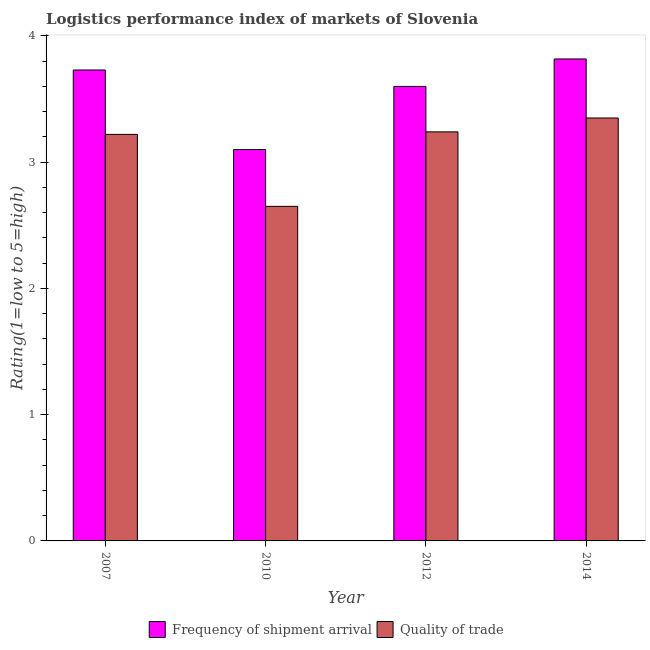How many groups of bars are there?
Provide a short and direct response. 4. Are the number of bars on each tick of the X-axis equal?
Ensure brevity in your answer.  Yes. What is the label of the 4th group of bars from the left?
Your answer should be compact. 2014. In how many cases, is the number of bars for a given year not equal to the number of legend labels?
Ensure brevity in your answer.  0. What is the lpi quality of trade in 2007?
Make the answer very short. 3.22. Across all years, what is the maximum lpi quality of trade?
Your answer should be compact. 3.35. Across all years, what is the minimum lpi quality of trade?
Offer a terse response. 2.65. In which year was the lpi quality of trade maximum?
Your answer should be compact. 2014. What is the total lpi quality of trade in the graph?
Provide a succinct answer. 12.46. What is the difference between the lpi of frequency of shipment arrival in 2007 and that in 2014?
Your answer should be very brief. -0.09. What is the difference between the lpi of frequency of shipment arrival in 2010 and the lpi quality of trade in 2014?
Offer a terse response. -0.72. What is the average lpi of frequency of shipment arrival per year?
Your response must be concise. 3.56. In the year 2012, what is the difference between the lpi quality of trade and lpi of frequency of shipment arrival?
Offer a terse response. 0. In how many years, is the lpi quality of trade greater than 3.6?
Your answer should be very brief. 0. What is the ratio of the lpi of frequency of shipment arrival in 2007 to that in 2014?
Keep it short and to the point. 0.98. What is the difference between the highest and the second highest lpi quality of trade?
Give a very brief answer. 0.11. What is the difference between the highest and the lowest lpi of frequency of shipment arrival?
Your response must be concise. 0.72. Is the sum of the lpi quality of trade in 2007 and 2010 greater than the maximum lpi of frequency of shipment arrival across all years?
Make the answer very short. Yes. What does the 1st bar from the left in 2014 represents?
Make the answer very short. Frequency of shipment arrival. What does the 1st bar from the right in 2007 represents?
Provide a short and direct response. Quality of trade. How many bars are there?
Give a very brief answer. 8. Are all the bars in the graph horizontal?
Make the answer very short. No. How many years are there in the graph?
Provide a succinct answer. 4. What is the difference between two consecutive major ticks on the Y-axis?
Offer a very short reply. 1. Does the graph contain grids?
Provide a short and direct response. No. What is the title of the graph?
Your response must be concise. Logistics performance index of markets of Slovenia. Does "Research and Development" appear as one of the legend labels in the graph?
Make the answer very short. No. What is the label or title of the Y-axis?
Give a very brief answer. Rating(1=low to 5=high). What is the Rating(1=low to 5=high) of Frequency of shipment arrival in 2007?
Provide a short and direct response. 3.73. What is the Rating(1=low to 5=high) in Quality of trade in 2007?
Your answer should be very brief. 3.22. What is the Rating(1=low to 5=high) of Frequency of shipment arrival in 2010?
Offer a very short reply. 3.1. What is the Rating(1=low to 5=high) in Quality of trade in 2010?
Your response must be concise. 2.65. What is the Rating(1=low to 5=high) in Frequency of shipment arrival in 2012?
Ensure brevity in your answer.  3.6. What is the Rating(1=low to 5=high) in Quality of trade in 2012?
Ensure brevity in your answer.  3.24. What is the Rating(1=low to 5=high) of Frequency of shipment arrival in 2014?
Give a very brief answer. 3.82. What is the Rating(1=low to 5=high) of Quality of trade in 2014?
Ensure brevity in your answer.  3.35. Across all years, what is the maximum Rating(1=low to 5=high) of Frequency of shipment arrival?
Give a very brief answer. 3.82. Across all years, what is the maximum Rating(1=low to 5=high) in Quality of trade?
Your response must be concise. 3.35. Across all years, what is the minimum Rating(1=low to 5=high) of Quality of trade?
Offer a terse response. 2.65. What is the total Rating(1=low to 5=high) in Frequency of shipment arrival in the graph?
Make the answer very short. 14.25. What is the total Rating(1=low to 5=high) in Quality of trade in the graph?
Ensure brevity in your answer.  12.46. What is the difference between the Rating(1=low to 5=high) in Frequency of shipment arrival in 2007 and that in 2010?
Make the answer very short. 0.63. What is the difference between the Rating(1=low to 5=high) of Quality of trade in 2007 and that in 2010?
Your response must be concise. 0.57. What is the difference between the Rating(1=low to 5=high) of Frequency of shipment arrival in 2007 and that in 2012?
Your answer should be compact. 0.13. What is the difference between the Rating(1=low to 5=high) in Quality of trade in 2007 and that in 2012?
Ensure brevity in your answer.  -0.02. What is the difference between the Rating(1=low to 5=high) in Frequency of shipment arrival in 2007 and that in 2014?
Offer a terse response. -0.09. What is the difference between the Rating(1=low to 5=high) of Quality of trade in 2007 and that in 2014?
Give a very brief answer. -0.13. What is the difference between the Rating(1=low to 5=high) in Quality of trade in 2010 and that in 2012?
Offer a very short reply. -0.59. What is the difference between the Rating(1=low to 5=high) in Frequency of shipment arrival in 2010 and that in 2014?
Your answer should be very brief. -0.72. What is the difference between the Rating(1=low to 5=high) in Quality of trade in 2010 and that in 2014?
Give a very brief answer. -0.7. What is the difference between the Rating(1=low to 5=high) of Frequency of shipment arrival in 2012 and that in 2014?
Provide a succinct answer. -0.22. What is the difference between the Rating(1=low to 5=high) of Quality of trade in 2012 and that in 2014?
Make the answer very short. -0.11. What is the difference between the Rating(1=low to 5=high) in Frequency of shipment arrival in 2007 and the Rating(1=low to 5=high) in Quality of trade in 2010?
Your response must be concise. 1.08. What is the difference between the Rating(1=low to 5=high) of Frequency of shipment arrival in 2007 and the Rating(1=low to 5=high) of Quality of trade in 2012?
Offer a terse response. 0.49. What is the difference between the Rating(1=low to 5=high) of Frequency of shipment arrival in 2007 and the Rating(1=low to 5=high) of Quality of trade in 2014?
Offer a very short reply. 0.38. What is the difference between the Rating(1=low to 5=high) of Frequency of shipment arrival in 2010 and the Rating(1=low to 5=high) of Quality of trade in 2012?
Provide a short and direct response. -0.14. What is the difference between the Rating(1=low to 5=high) of Frequency of shipment arrival in 2010 and the Rating(1=low to 5=high) of Quality of trade in 2014?
Your answer should be very brief. -0.25. What is the difference between the Rating(1=low to 5=high) of Frequency of shipment arrival in 2012 and the Rating(1=low to 5=high) of Quality of trade in 2014?
Your response must be concise. 0.25. What is the average Rating(1=low to 5=high) of Frequency of shipment arrival per year?
Your answer should be very brief. 3.56. What is the average Rating(1=low to 5=high) of Quality of trade per year?
Provide a short and direct response. 3.12. In the year 2007, what is the difference between the Rating(1=low to 5=high) of Frequency of shipment arrival and Rating(1=low to 5=high) of Quality of trade?
Provide a short and direct response. 0.51. In the year 2010, what is the difference between the Rating(1=low to 5=high) of Frequency of shipment arrival and Rating(1=low to 5=high) of Quality of trade?
Keep it short and to the point. 0.45. In the year 2012, what is the difference between the Rating(1=low to 5=high) in Frequency of shipment arrival and Rating(1=low to 5=high) in Quality of trade?
Give a very brief answer. 0.36. In the year 2014, what is the difference between the Rating(1=low to 5=high) of Frequency of shipment arrival and Rating(1=low to 5=high) of Quality of trade?
Provide a succinct answer. 0.47. What is the ratio of the Rating(1=low to 5=high) of Frequency of shipment arrival in 2007 to that in 2010?
Keep it short and to the point. 1.2. What is the ratio of the Rating(1=low to 5=high) of Quality of trade in 2007 to that in 2010?
Keep it short and to the point. 1.22. What is the ratio of the Rating(1=low to 5=high) in Frequency of shipment arrival in 2007 to that in 2012?
Provide a succinct answer. 1.04. What is the ratio of the Rating(1=low to 5=high) of Frequency of shipment arrival in 2007 to that in 2014?
Provide a short and direct response. 0.98. What is the ratio of the Rating(1=low to 5=high) of Quality of trade in 2007 to that in 2014?
Keep it short and to the point. 0.96. What is the ratio of the Rating(1=low to 5=high) in Frequency of shipment arrival in 2010 to that in 2012?
Keep it short and to the point. 0.86. What is the ratio of the Rating(1=low to 5=high) in Quality of trade in 2010 to that in 2012?
Provide a succinct answer. 0.82. What is the ratio of the Rating(1=low to 5=high) of Frequency of shipment arrival in 2010 to that in 2014?
Ensure brevity in your answer.  0.81. What is the ratio of the Rating(1=low to 5=high) of Quality of trade in 2010 to that in 2014?
Make the answer very short. 0.79. What is the ratio of the Rating(1=low to 5=high) in Frequency of shipment arrival in 2012 to that in 2014?
Provide a short and direct response. 0.94. What is the ratio of the Rating(1=low to 5=high) in Quality of trade in 2012 to that in 2014?
Offer a very short reply. 0.97. What is the difference between the highest and the second highest Rating(1=low to 5=high) of Frequency of shipment arrival?
Ensure brevity in your answer.  0.09. What is the difference between the highest and the second highest Rating(1=low to 5=high) in Quality of trade?
Keep it short and to the point. 0.11. What is the difference between the highest and the lowest Rating(1=low to 5=high) in Frequency of shipment arrival?
Provide a succinct answer. 0.72. What is the difference between the highest and the lowest Rating(1=low to 5=high) of Quality of trade?
Your answer should be very brief. 0.7. 